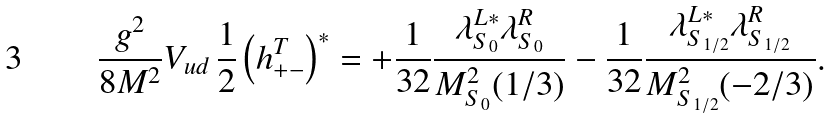Convert formula to latex. <formula><loc_0><loc_0><loc_500><loc_500>\frac { g ^ { 2 } } { 8 M ^ { 2 } } V _ { u d } \, \frac { 1 } { 2 } \left ( h ^ { T } _ { + - } \right ) ^ { * } = + \frac { 1 } { 3 2 } \frac { \lambda ^ { L * } _ { S _ { 0 } } \lambda ^ { R } _ { S _ { 0 } } } { M ^ { 2 } _ { S _ { 0 } } ( 1 / 3 ) } - \frac { 1 } { 3 2 } \frac { \lambda ^ { L * } _ { S _ { 1 / 2 } } \lambda ^ { R } _ { S _ { 1 / 2 } } } { M ^ { 2 } _ { S _ { 1 / 2 } } ( - 2 / 3 ) } .</formula> 